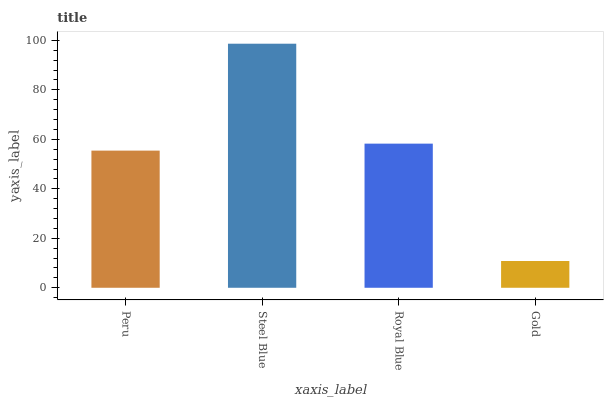Is Gold the minimum?
Answer yes or no. Yes. Is Steel Blue the maximum?
Answer yes or no. Yes. Is Royal Blue the minimum?
Answer yes or no. No. Is Royal Blue the maximum?
Answer yes or no. No. Is Steel Blue greater than Royal Blue?
Answer yes or no. Yes. Is Royal Blue less than Steel Blue?
Answer yes or no. Yes. Is Royal Blue greater than Steel Blue?
Answer yes or no. No. Is Steel Blue less than Royal Blue?
Answer yes or no. No. Is Royal Blue the high median?
Answer yes or no. Yes. Is Peru the low median?
Answer yes or no. Yes. Is Peru the high median?
Answer yes or no. No. Is Gold the low median?
Answer yes or no. No. 